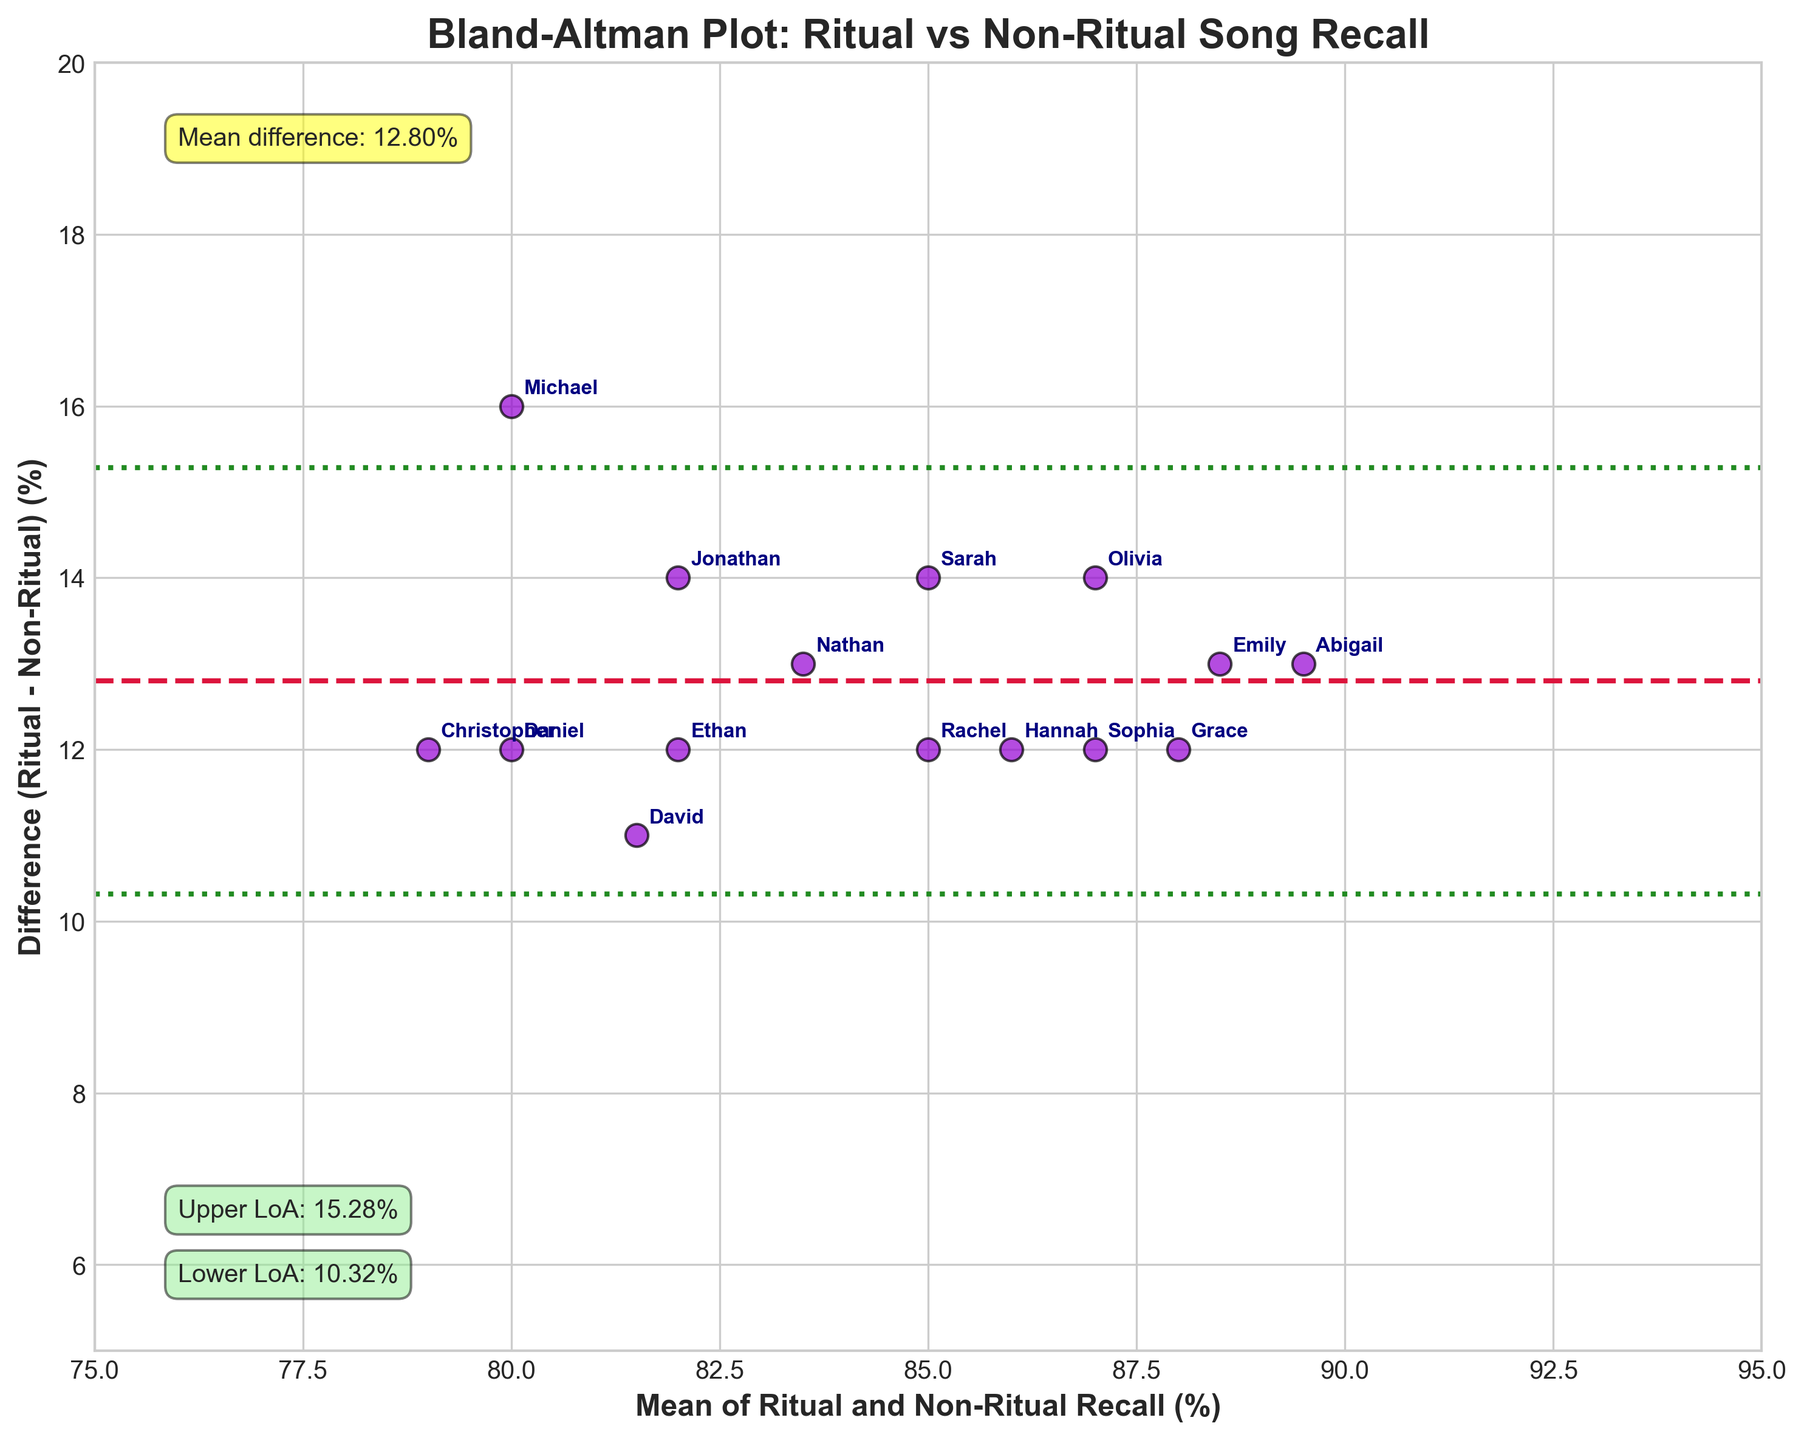what does the y-axis represent in the plot? The y-axis of the Bland-Altman plot represents the difference in memory recall accuracy between ritual-related and non-ritual song lyrics. This is calculated as the recall percentage for ritual songs minus the recall percentage for non-ritual songs.
Answer: difference in recall (%) What's the title of the plot? The title of the plot is displayed at the top of the figure. By observing it, we can read that it refers to the comparison of memory recall through a specific visualization method.
Answer: Bland-Altman Plot: Ritual vs Non-Ritual Song Recall How many participants are represented in the plot? Each participant's recall data is represented as a point on the plot. By counting these points, we can determine the number of participants.
Answer: 15 What is roughly the mean difference in recall between ritual-related and non-ritual song lyrics? In the plot, the mean difference is indicated by the horizontal dashed line labeled "Mean difference". The text annotation next to this line provides the specific value.
Answer: 10.07% What do the green dotted horizontal lines represent? The green dotted lines show the limits of agreement, which are calculated as the mean difference plus or minus 1.96 times the standard deviation of the differences. These lines provide a range to evaluate the spread of differences.
Answer: limits of agreement Which participant has the highest mean recall? The mean recall value for each participant can be identified by locating their point on the x-axis and finding the one with the highest mean value. The text annotation associated with each point helps in identification.
Answer: Abigail What is the range of the differences in recall percentages? To find the range, observe the y-axis values of the lowest and highest points on the plot. The range is the difference between these two y-axis values.
Answer: 7% - 23% Do ritual songs have higher recall on average compared to non-ritual songs? The y-axis represents the differences (Ritual - Non-Ritual). If most points are above zero, it suggests higher recall for ritual songs. The plot shows that most differences are positive.
Answer: Yes Is the mean difference closer to the upper or lower limit of agreement? Observe the mean difference and compare it to the upper and lower limits of agreement. The text annotations next to these lines provide the exact values.
Answer: Closer to the lower limit Are there any outliers in the differences observed among participants? Outliers in a Bland-Altman plot can be identified by looking for points that fall far from the mean difference or outside the limits of agreement lines.
Answer: No 